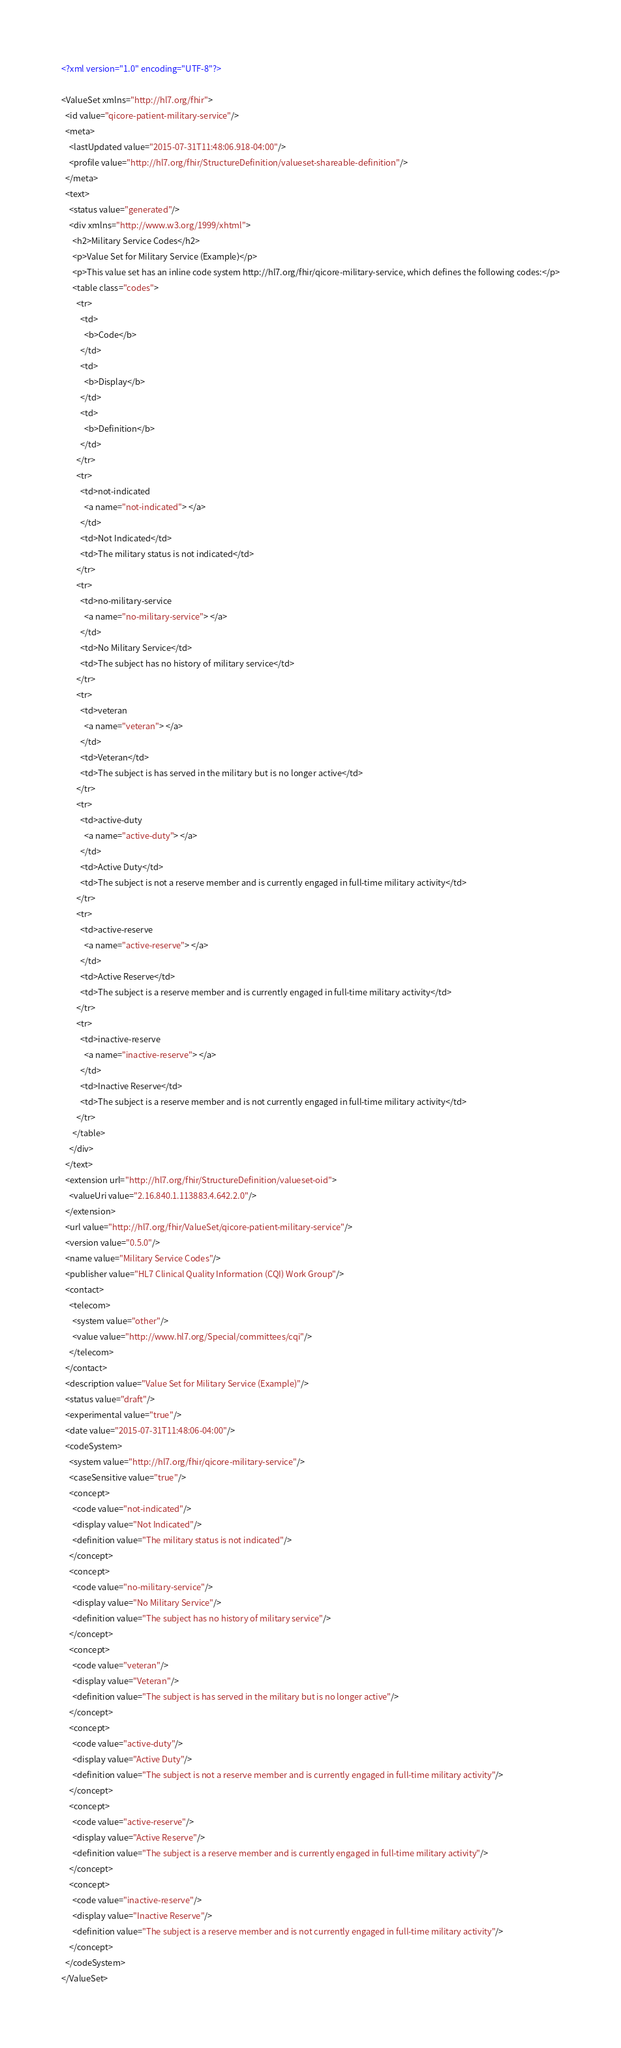Convert code to text. <code><loc_0><loc_0><loc_500><loc_500><_XML_><?xml version="1.0" encoding="UTF-8"?>

<ValueSet xmlns="http://hl7.org/fhir">
  <id value="qicore-patient-military-service"/>
  <meta>
    <lastUpdated value="2015-07-31T11:48:06.918-04:00"/>
    <profile value="http://hl7.org/fhir/StructureDefinition/valueset-shareable-definition"/>
  </meta>
  <text>
    <status value="generated"/>
    <div xmlns="http://www.w3.org/1999/xhtml">
      <h2>Military Service Codes</h2>
      <p>Value Set for Military Service (Example)</p>
      <p>This value set has an inline code system http://hl7.org/fhir/qicore-military-service, which defines the following codes:</p>
      <table class="codes">
        <tr>
          <td>
            <b>Code</b>
          </td>
          <td>
            <b>Display</b>
          </td>
          <td>
            <b>Definition</b>
          </td>
        </tr>
        <tr>
          <td>not-indicated
            <a name="not-indicated"> </a>
          </td>
          <td>Not Indicated</td>
          <td>The military status is not indicated</td>
        </tr>
        <tr>
          <td>no-military-service
            <a name="no-military-service"> </a>
          </td>
          <td>No Military Service</td>
          <td>The subject has no history of military service</td>
        </tr>
        <tr>
          <td>veteran
            <a name="veteran"> </a>
          </td>
          <td>Veteran</td>
          <td>The subject is has served in the military but is no longer active</td>
        </tr>
        <tr>
          <td>active-duty
            <a name="active-duty"> </a>
          </td>
          <td>Active Duty</td>
          <td>The subject is not a reserve member and is currently engaged in full-time military activity</td>
        </tr>
        <tr>
          <td>active-reserve
            <a name="active-reserve"> </a>
          </td>
          <td>Active Reserve</td>
          <td>The subject is a reserve member and is currently engaged in full-time military activity</td>
        </tr>
        <tr>
          <td>inactive-reserve
            <a name="inactive-reserve"> </a>
          </td>
          <td>Inactive Reserve</td>
          <td>The subject is a reserve member and is not currently engaged in full-time military activity</td>
        </tr>
      </table>
    </div>
  </text>
  <extension url="http://hl7.org/fhir/StructureDefinition/valueset-oid">
    <valueUri value="2.16.840.1.113883.4.642.2.0"/>
  </extension>
  <url value="http://hl7.org/fhir/ValueSet/qicore-patient-military-service"/>
  <version value="0.5.0"/>
  <name value="Military Service Codes"/>
  <publisher value="HL7 Clinical Quality Information (CQI) Work Group"/>
  <contact>
    <telecom>
      <system value="other"/>
      <value value="http://www.hl7.org/Special/committees/cqi"/>
    </telecom>
  </contact>
  <description value="Value Set for Military Service (Example)"/>
  <status value="draft"/>
  <experimental value="true"/>
  <date value="2015-07-31T11:48:06-04:00"/>
  <codeSystem>
    <system value="http://hl7.org/fhir/qicore-military-service"/>
    <caseSensitive value="true"/>
    <concept>
      <code value="not-indicated"/>
      <display value="Not Indicated"/>
      <definition value="The military status is not indicated"/>
    </concept>
    <concept>
      <code value="no-military-service"/>
      <display value="No Military Service"/>
      <definition value="The subject has no history of military service"/>
    </concept>
    <concept>
      <code value="veteran"/>
      <display value="Veteran"/>
      <definition value="The subject is has served in the military but is no longer active"/>
    </concept>
    <concept>
      <code value="active-duty"/>
      <display value="Active Duty"/>
      <definition value="The subject is not a reserve member and is currently engaged in full-time military activity"/>
    </concept>
    <concept>
      <code value="active-reserve"/>
      <display value="Active Reserve"/>
      <definition value="The subject is a reserve member and is currently engaged in full-time military activity"/>
    </concept>
    <concept>
      <code value="inactive-reserve"/>
      <display value="Inactive Reserve"/>
      <definition value="The subject is a reserve member and is not currently engaged in full-time military activity"/>
    </concept>
  </codeSystem>
</ValueSet></code> 